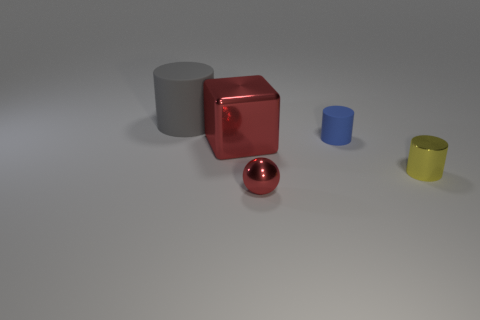Add 1 tiny cyan metallic objects. How many objects exist? 6 Subtract all balls. How many objects are left? 4 Subtract all tiny blue cylinders. How many cylinders are left? 2 Subtract all yellow cylinders. How many cylinders are left? 2 Subtract all red cubes. How many yellow cylinders are left? 1 Subtract all big green spheres. Subtract all small yellow metallic cylinders. How many objects are left? 4 Add 5 yellow cylinders. How many yellow cylinders are left? 6 Add 2 rubber blocks. How many rubber blocks exist? 2 Subtract 1 blue cylinders. How many objects are left? 4 Subtract all green spheres. Subtract all yellow cubes. How many spheres are left? 1 